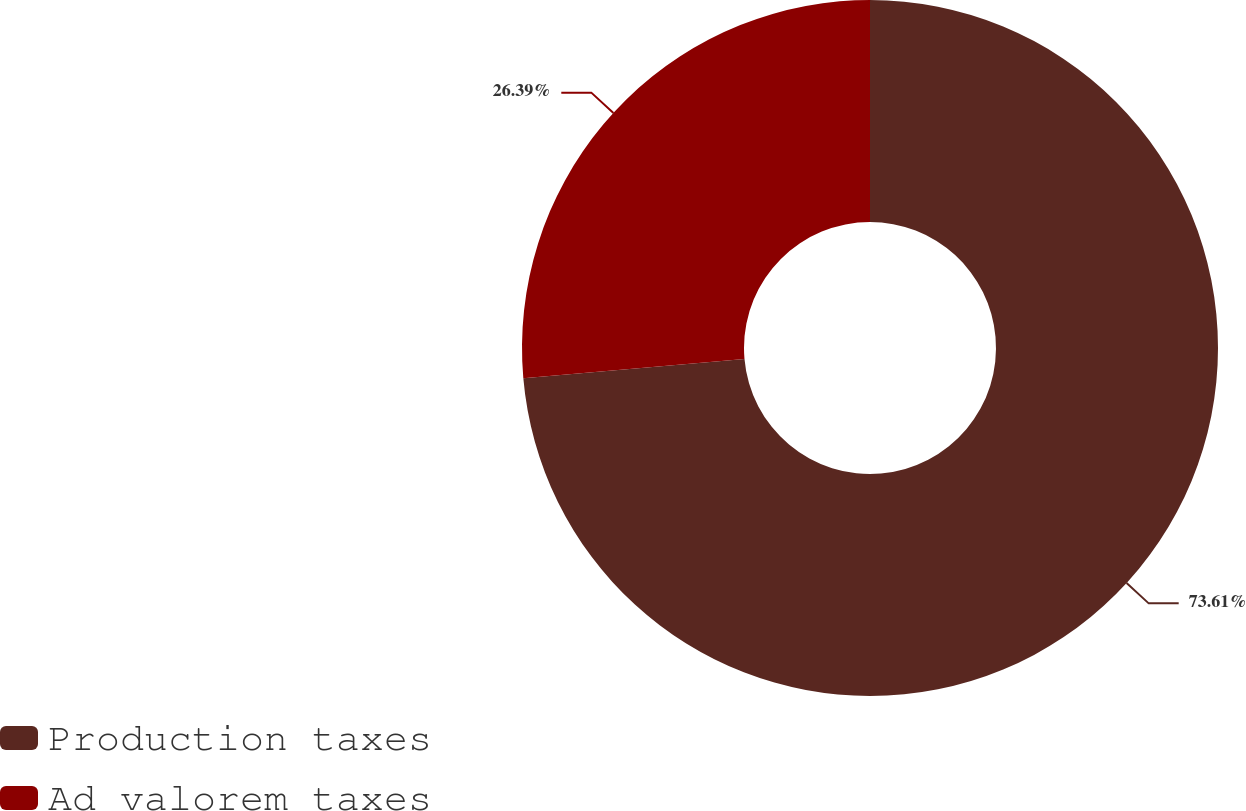Convert chart. <chart><loc_0><loc_0><loc_500><loc_500><pie_chart><fcel>Production taxes<fcel>Ad valorem taxes<nl><fcel>73.61%<fcel>26.39%<nl></chart> 